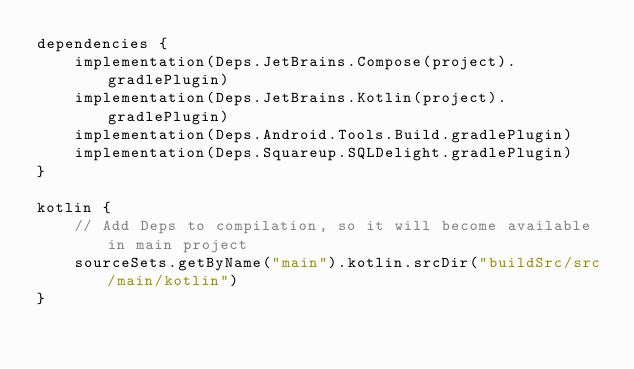Convert code to text. <code><loc_0><loc_0><loc_500><loc_500><_Kotlin_>dependencies {
    implementation(Deps.JetBrains.Compose(project).gradlePlugin)
    implementation(Deps.JetBrains.Kotlin(project).gradlePlugin)
    implementation(Deps.Android.Tools.Build.gradlePlugin)
    implementation(Deps.Squareup.SQLDelight.gradlePlugin)
}

kotlin {
    // Add Deps to compilation, so it will become available in main project
    sourceSets.getByName("main").kotlin.srcDir("buildSrc/src/main/kotlin")
}
</code> 